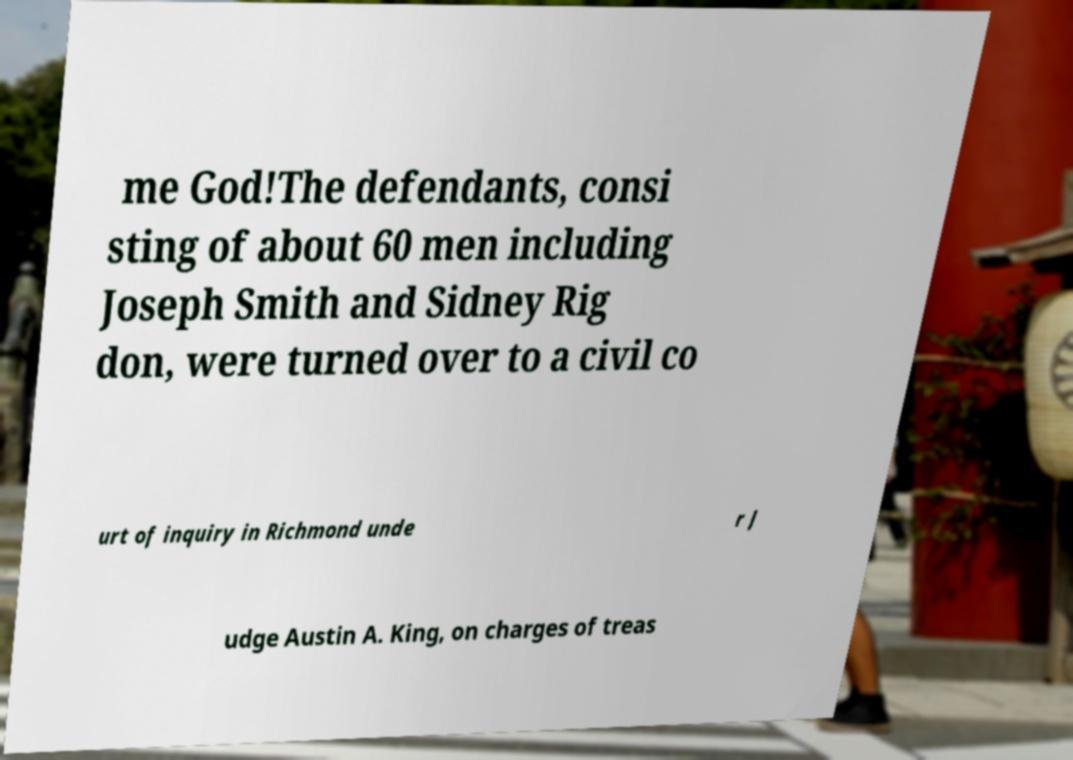What messages or text are displayed in this image? I need them in a readable, typed format. me God!The defendants, consi sting of about 60 men including Joseph Smith and Sidney Rig don, were turned over to a civil co urt of inquiry in Richmond unde r J udge Austin A. King, on charges of treas 